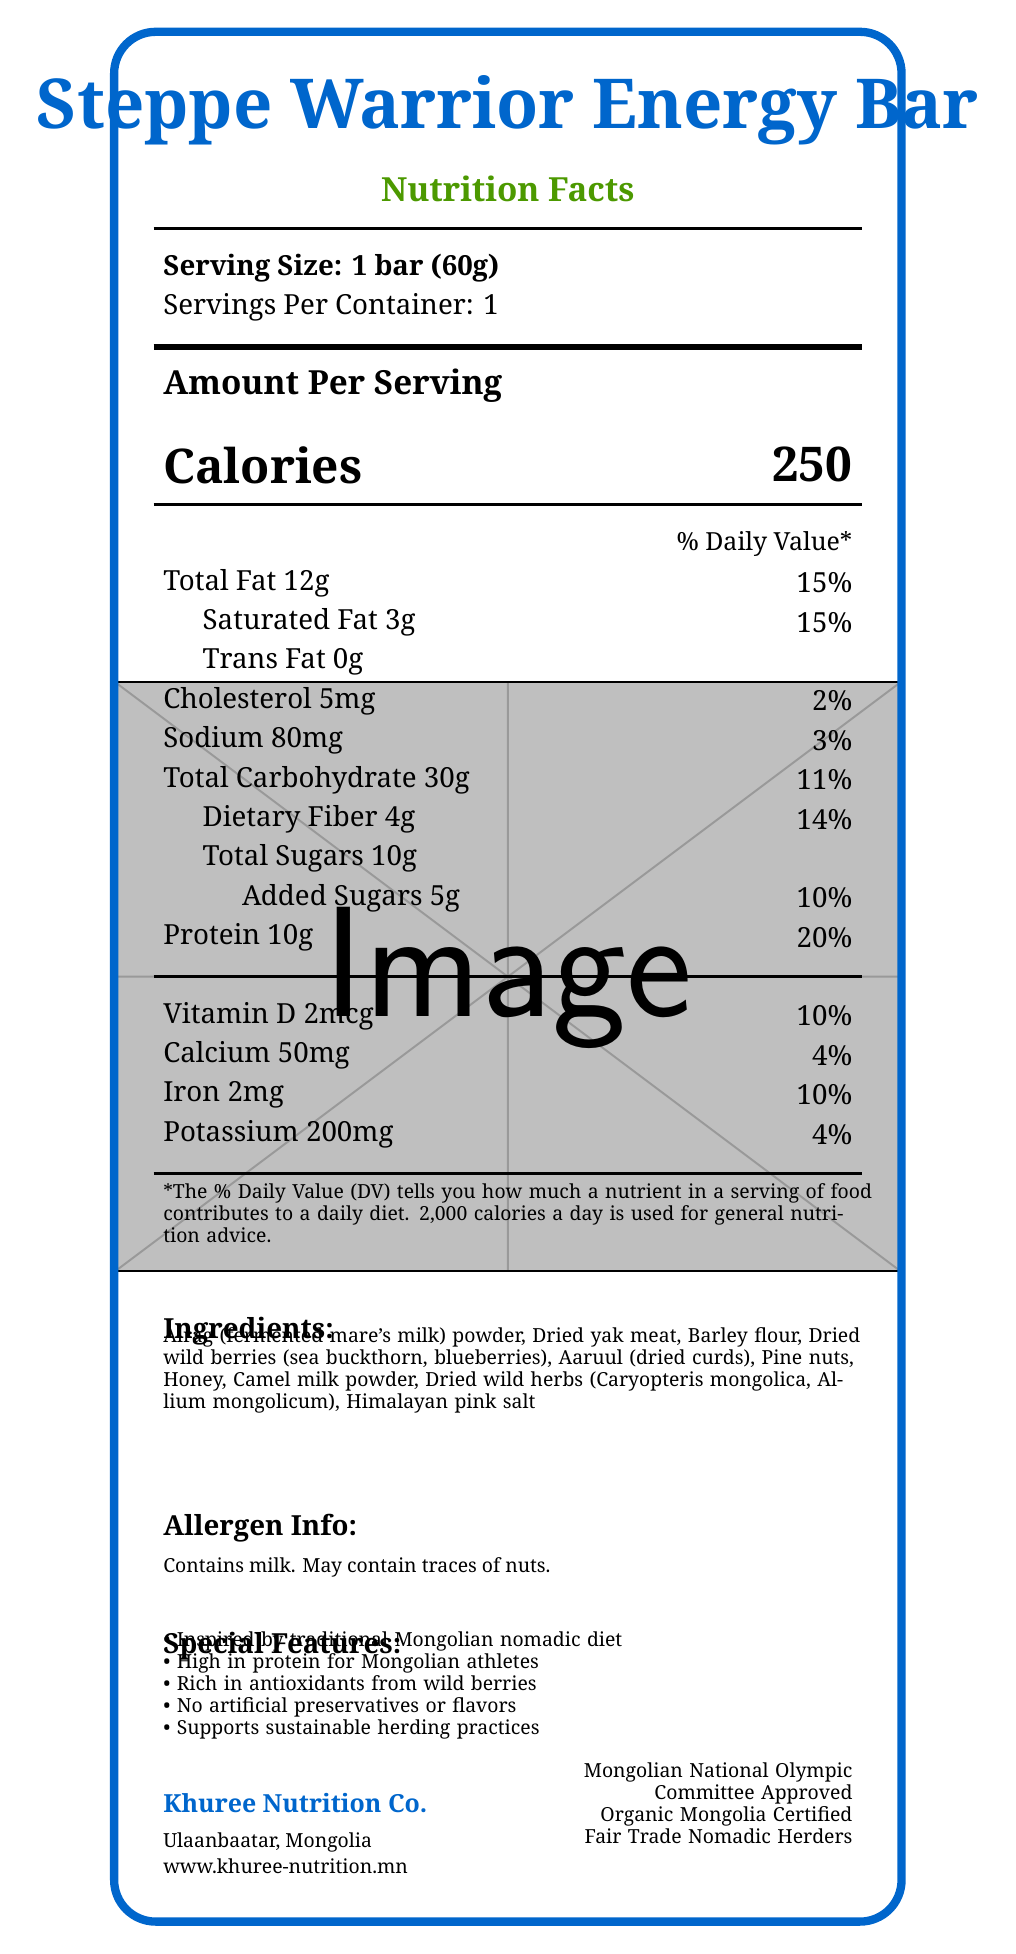what is the serving size of the Steppe Warrior Energy Bar? The serving size is explicitly mentioned at the top of the Nutrition Facts section.
Answer: 1 bar (60g) how many calories are in one serving of the Steppe Warrior Energy Bar? The calories per serving are prominently listed next to "Calories" in the Nutrition Facts section.
Answer: 250 how much protein does the Steppe Warrior Energy Bar contain per serving? The protein amount is listed under "Protein" along with its daily value percentage.
Answer: 10g what percentage of the daily value of saturated fat does one bar provide? The daily value percentage for saturated fat is listed next to "Saturated Fat 3g".
Answer: 15% what is the first ingredient listed for the Steppe Warrior Energy Bar? The first ingredient listed is Airag, which can be found under the Ingredients section.
Answer: Airag (fermented mare's milk) powder which ingredient gives the Steppe Warrior Energy Bar its sweet flavor? A. Airag powder B. Honey C. Dried wild herbs Honey is listed among the ingredients and is known for its sweet flavor.
Answer: B how much Vitamin D does the bar contain? A. 2% B. 4% C. 10% D. 20% The bar contains 10% of the daily value for Vitamin D, as indicated in the Nutrition Facts section.
Answer: C which certification is not listed for the Steppe Warrior Energy Bar? A. Fair Trade Nomadic Herders B. USDA Organic C. Organic Mongolia Certified D. Mongolian National Olympic Committee Approved USDA Organic is not listed among the certifications; the others are mentioned at the bottom of the document.
Answer: B does the Steppe Warrior Energy Bar contain trans fat? The Nutrition Facts section explicitly states that the Trans Fat content is "0g".
Answer: No summarize the main idea of the Steppe Warrior Energy Bar's packaging. The document describes the nutritional content, ingredients, special features, allergen information, manufacturer details, and certifications, all emphasizing its inspiration from traditional Mongolian culture and its suitability for athletes.
Answer: The Steppe Warrior Energy Bar is a high-protein energy bar inspired by the traditional Mongolian nomadic diet. It features ingredients such as Airag powder, dried yak meat, and wild berries, and is designed especially for athletes. It is certified organic and fair trade, supports sustainable practices, and contains no artificial preservatives or flavors. how does the Steppe Warrior Energy Bar support sustainable practices? One of the special features listed emphasizes that the product supports sustainable herding practices.
Answer: Supports sustainable herding practices what is the amount of dietary fiber per serving? The amount of dietary fiber is listed under "Dietary Fiber" in the Nutrition Facts section.
Answer: 4g which Mongolian wild herbs are included in the ingredients? The ingredients list includes dried wild herbs, specifically Caryopteris mongolica and Allium mongolicum.
Answer: Caryopteris mongolica, Allium mongolicum what is the manufacturing location of the Steppe Warrior Energy Bar? The manufacturing location is listed under the manufacturer information as Ulaanbaatar, Mongolia.
Answer: Ulaanbaatar, Mongolia who is the manufacturer of the Steppe Warrior Energy Bar? The manufacturer's name is listed at the bottom of the document as Khuree Nutrition Co.
Answer: Khuree Nutrition Co. how much cholesterol is in a serving of the Steppe Warrior Energy Bar? The amount of cholesterol per serving is listed as 5mg in the Nutrition Facts section.
Answer: 5mg what is the daily value percentage of calcium provided by the bar? The daily value percentage for calcium is listed as 4% in the Nutrition Facts section.
Answer: 4% what is the website of the manufacturer? The website is provided at the bottom of the document along with other manufacturer details.
Answer: www.khuree-nutrition.mn which traditional Mongolian ingredient provides protein in the Steppe Warrior Energy Bar? A. Aaruul B. Barley flour C. Himalayan pink salt Aaruul, which is dried curds, is the ingredient likely contributing to the protein content.
Answer: A what essential nutrient information is missing from the Nutrition Facts? There is insufficient visual information to determine if any essential nutrient information is missing from the Nutrition Facts section.
Answer: Not enough information 